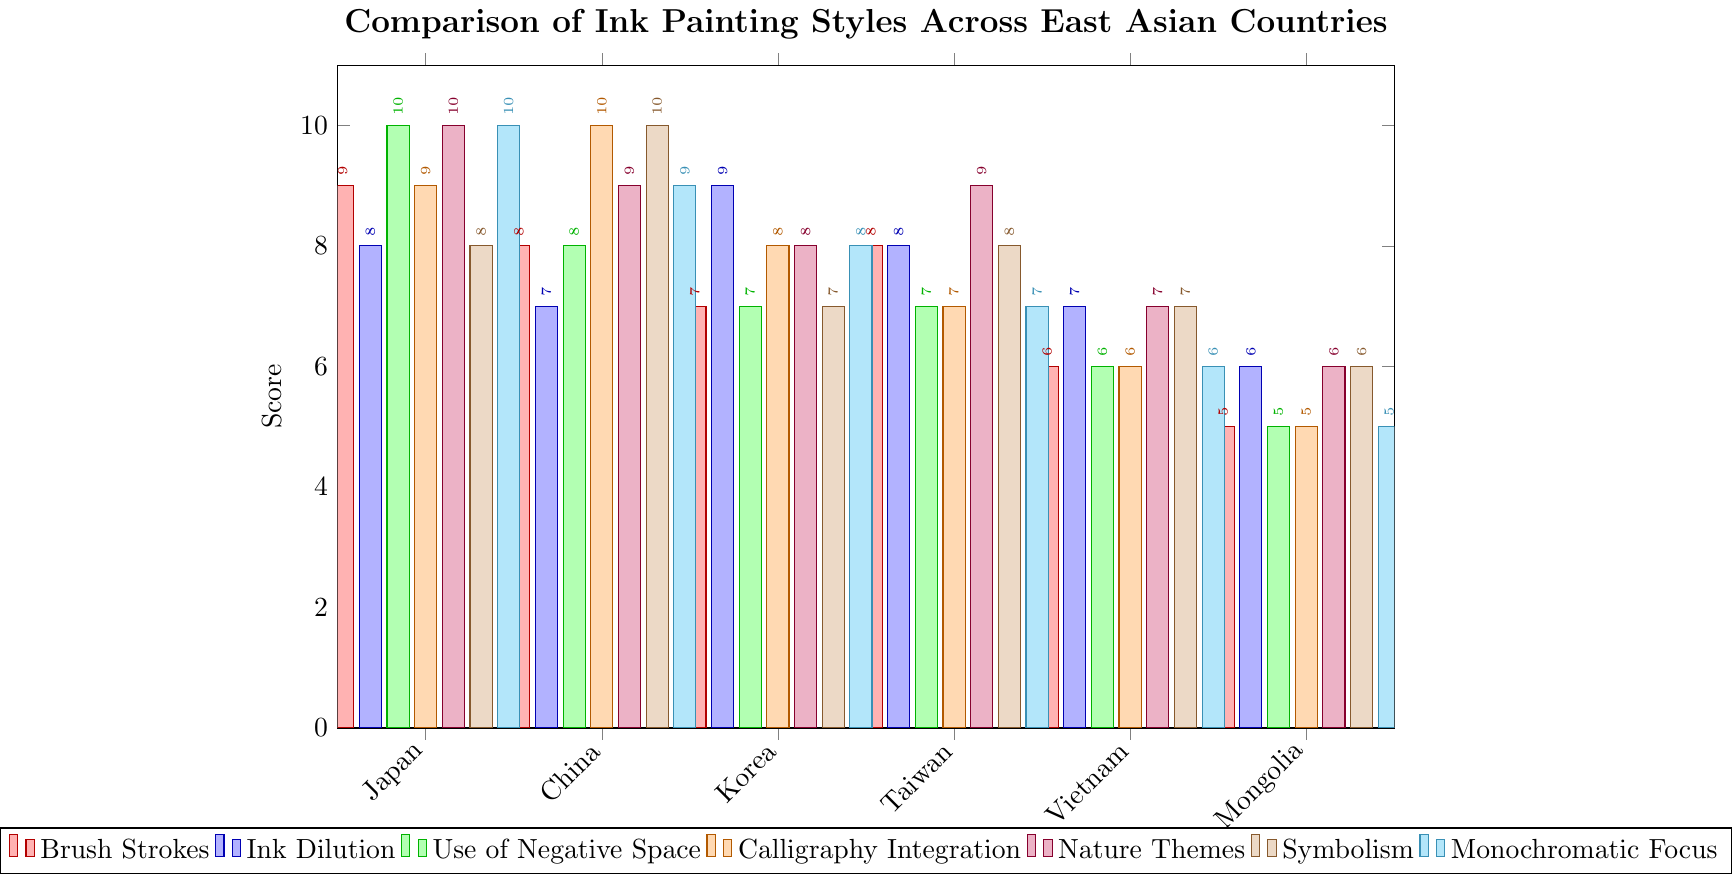What's the score for Brush Strokes in Japan and Mongolia? To find the answer, locate the Brush Strokes bar for both Japan and Mongolia. The bars for Brush Strokes are shown in red. Japan has a score of 9 and Mongolia has a score of 5.
Answer: Japan: 9, Mongolia: 5 Which country has the highest score for Calligraphy Integration? Look for the tallest bar in the Calligraphy Integration series, which is colored in orange. The highest score for Calligraphy Integration is 10, which belongs to China.
Answer: China What is the difference in scores for Nature Themes between Japan and Vietnam? Locate the Nature Themes bars for Japan and Vietnam. Japan's bar is at 10 and Vietnam's is at 7. Subtract Vietnam's score from Japan's score: 10 - 7 = 3.
Answer: 3 Which country has the lowest score in Symbolism? Find the shortest bar in the Symbolism series, which is colored in brown. The lowest score in this category is 6, belonging to Vietnam and Mongolia.
Answer: Vietnam and Mongolia What is the average score of Monochromatic Focus across all countries? Add the scores of Monochromatic Focus for all countries: 10 (Japan) + 9 (China) + 8 (Korea) + 7 (Taiwan) + 6 (Vietnam) + 5 (Mongolia) = 45. Divide by the number of countries (6): 45 / 6 = 7.5.
Answer: 7.5 How do the Brush Strokes scores compare between Japan and Korea? Look for the Brush Strokes scores for Japan and Korea. Japan has a score of 9 while Korea has a score of 7. Japan's score is higher.
Answer: Japan's is higher Which country scores equally in Ink Dilution and Use of Negative Space? Look for the bars of Ink Dilution and Use of Negative Space for each country. Taiwan has scores of 8 for both categories.
Answer: Taiwan Among all countries, which one has the most consistent scores across all seven categories? To find the most consistent scores, look at the variations in the heights of the bars for each country. Japan and China have relatively consistent (high and closely clustered) scores.
Answer: Japan and China 